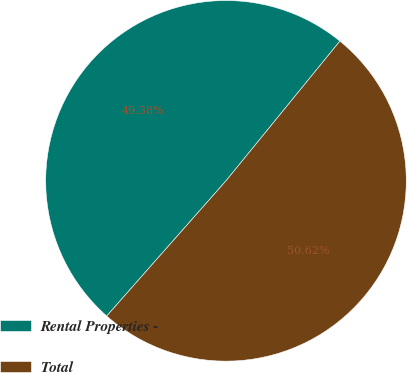<chart> <loc_0><loc_0><loc_500><loc_500><pie_chart><fcel>Rental Properties -<fcel>Total<nl><fcel>49.38%<fcel>50.62%<nl></chart> 